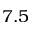<formula> <loc_0><loc_0><loc_500><loc_500>7 . 5</formula> 